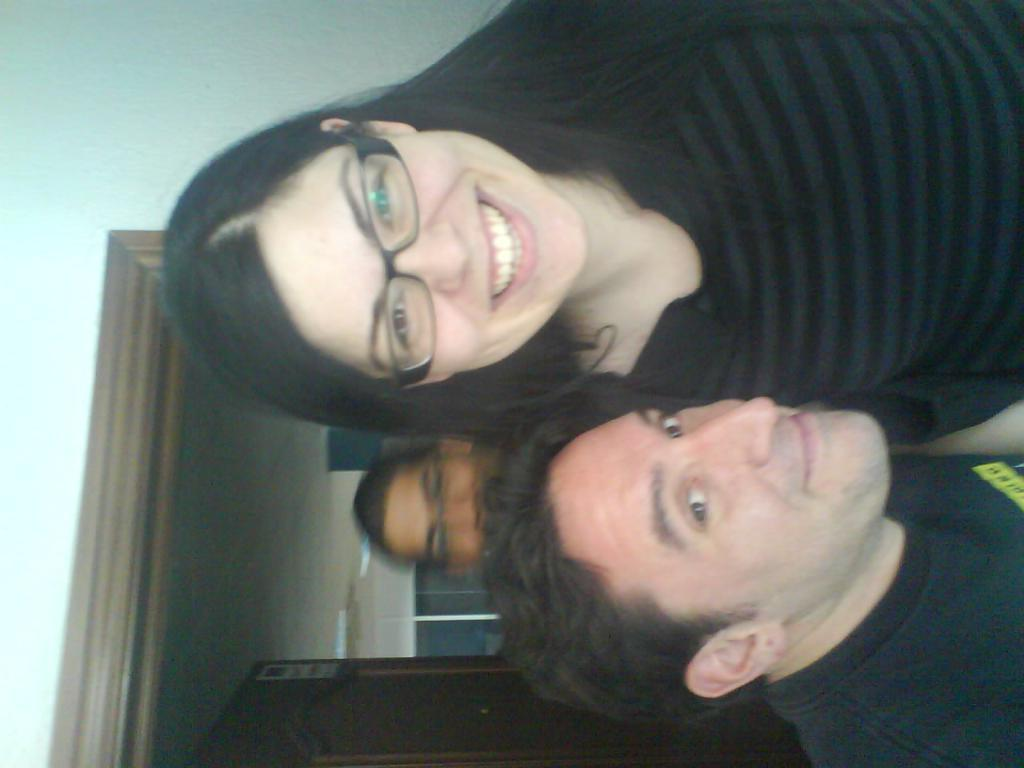How many people are in the image? There are persons in the image, but the exact number is not specified. What is the facial expression of the persons in the image? The persons in the image are smiling. What can be seen in the background of the image? There is a door and a wall in the background of the image. What color is the tongue of the person in the image? There is no mention of a tongue in the image, so it cannot be determined. 